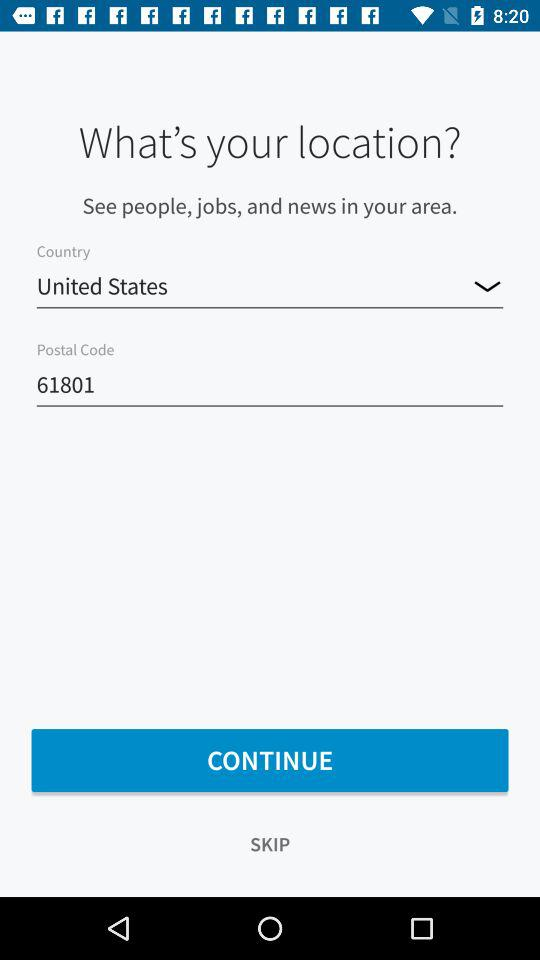What is the postal code? The postal code is 61801. 